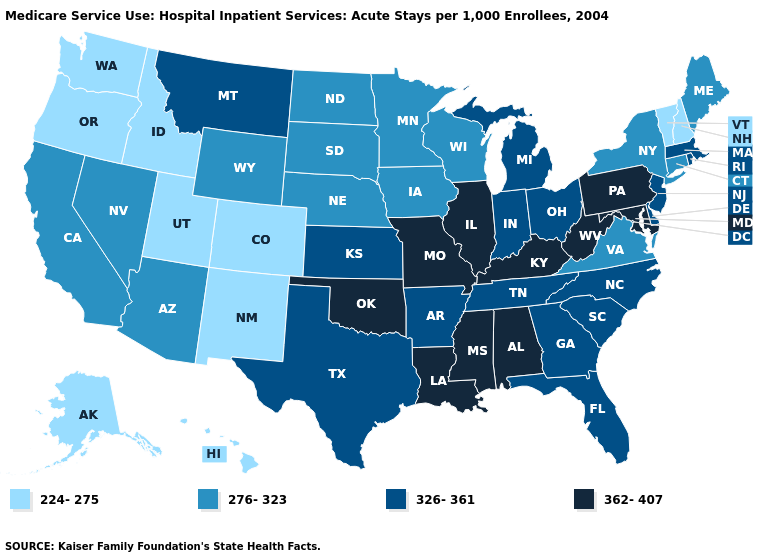Name the states that have a value in the range 224-275?
Concise answer only. Alaska, Colorado, Hawaii, Idaho, New Hampshire, New Mexico, Oregon, Utah, Vermont, Washington. Does Pennsylvania have the same value as Missouri?
Write a very short answer. Yes. What is the value of Michigan?
Give a very brief answer. 326-361. What is the lowest value in the South?
Short answer required. 276-323. Does West Virginia have the highest value in the South?
Short answer required. Yes. Among the states that border Indiana , does Michigan have the highest value?
Give a very brief answer. No. Does Washington have the lowest value in the USA?
Short answer required. Yes. Name the states that have a value in the range 224-275?
Keep it brief. Alaska, Colorado, Hawaii, Idaho, New Hampshire, New Mexico, Oregon, Utah, Vermont, Washington. What is the value of Alabama?
Concise answer only. 362-407. Name the states that have a value in the range 326-361?
Answer briefly. Arkansas, Delaware, Florida, Georgia, Indiana, Kansas, Massachusetts, Michigan, Montana, New Jersey, North Carolina, Ohio, Rhode Island, South Carolina, Tennessee, Texas. Name the states that have a value in the range 276-323?
Give a very brief answer. Arizona, California, Connecticut, Iowa, Maine, Minnesota, Nebraska, Nevada, New York, North Dakota, South Dakota, Virginia, Wisconsin, Wyoming. Is the legend a continuous bar?
Be succinct. No. Does Arkansas have the highest value in the USA?
Concise answer only. No. What is the lowest value in states that border Washington?
Keep it brief. 224-275. Does Iowa have a lower value than Nevada?
Give a very brief answer. No. 